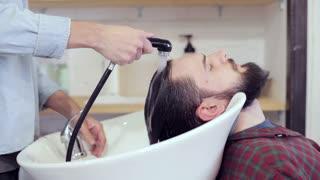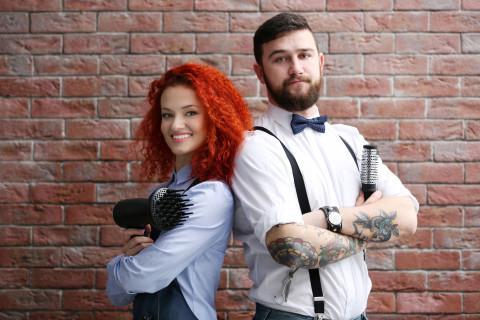The first image is the image on the left, the second image is the image on the right. Evaluate the accuracy of this statement regarding the images: "One image shows hair stylists posing with folded arms, without customers.". Is it true? Answer yes or no. Yes. The first image is the image on the left, the second image is the image on the right. Analyze the images presented: Is the assertion "Barber stylists stand with their arms crossed in one image, while a patron receives a barbershop service in the other image." valid? Answer yes or no. Yes. 